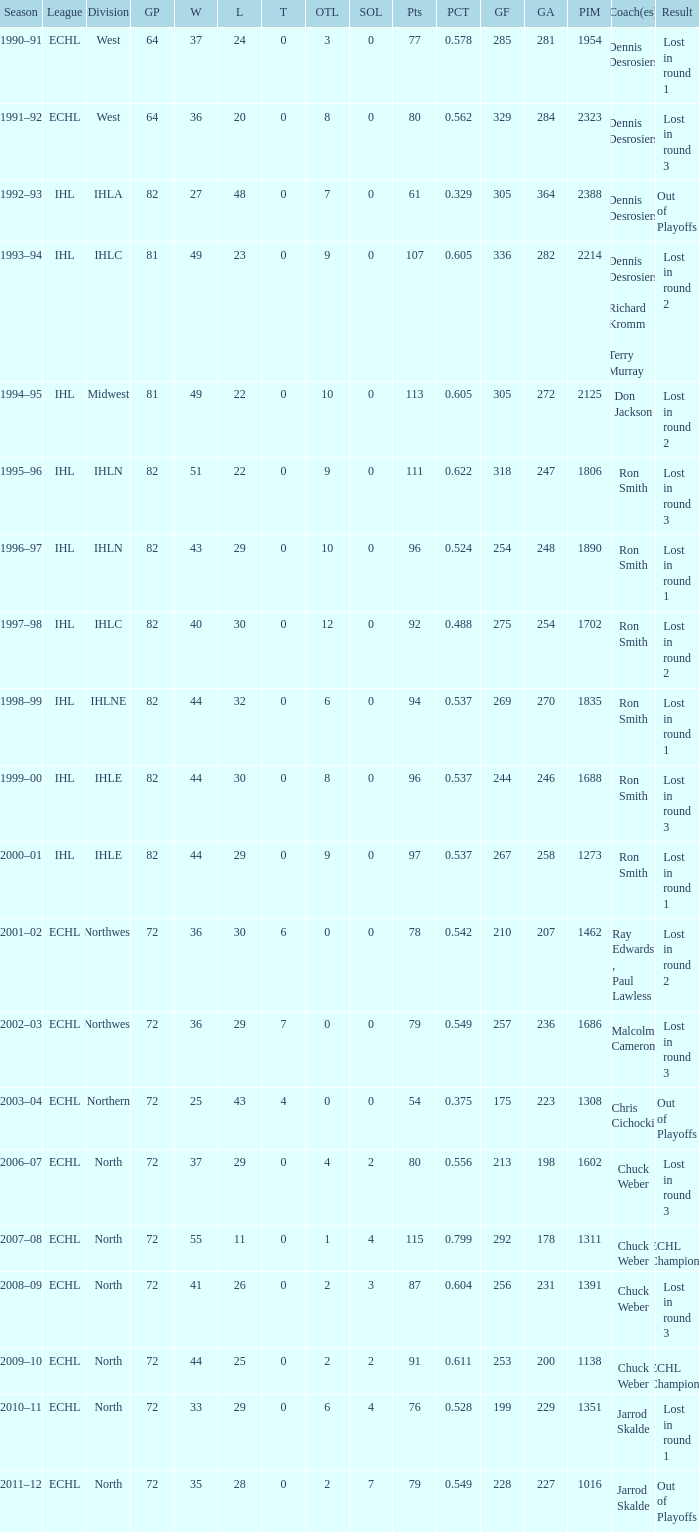During what season was the team able to attain a gp of 244? 1999–00. 